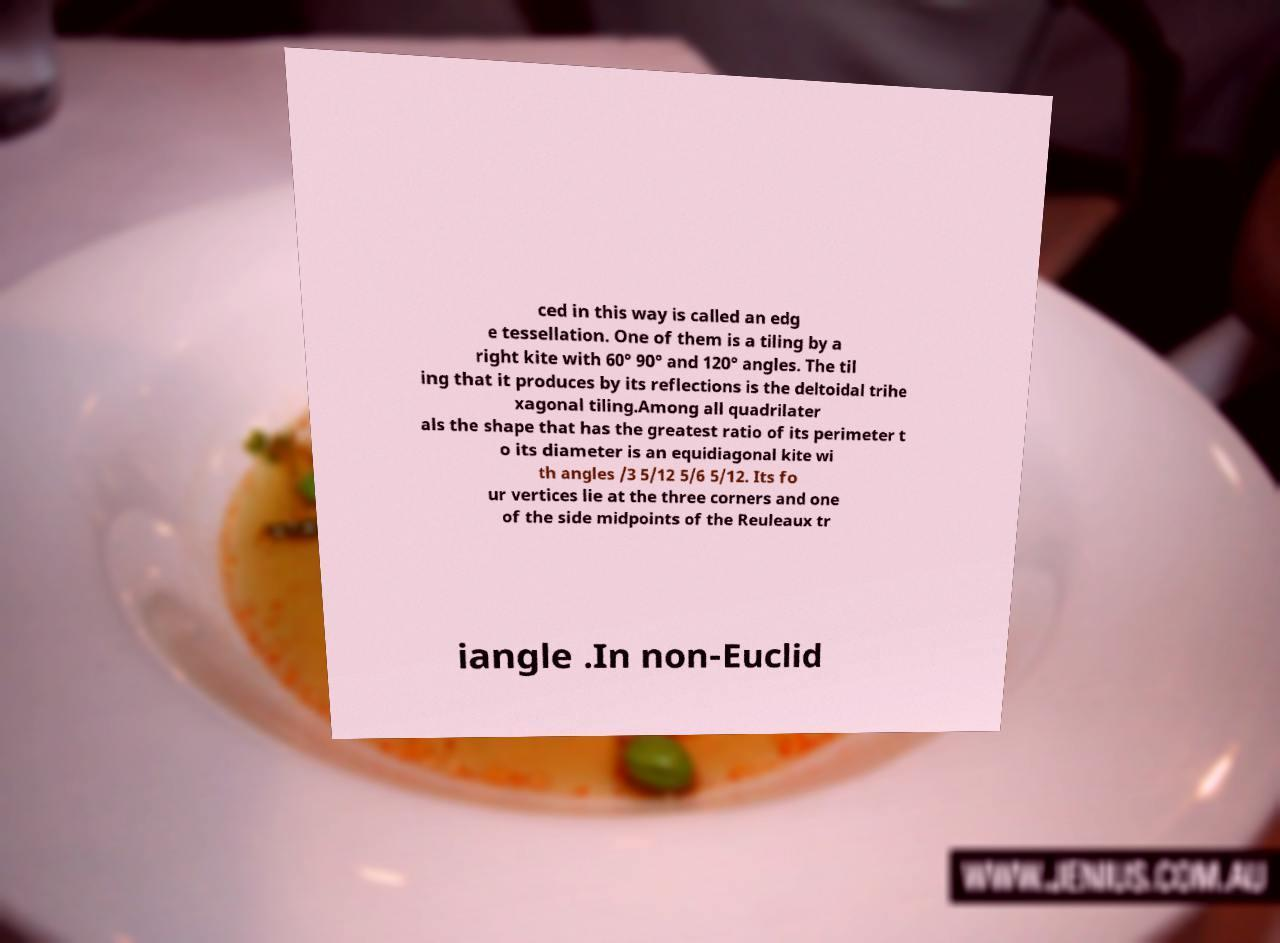Can you read and provide the text displayed in the image?This photo seems to have some interesting text. Can you extract and type it out for me? ced in this way is called an edg e tessellation. One of them is a tiling by a right kite with 60° 90° and 120° angles. The til ing that it produces by its reflections is the deltoidal trihe xagonal tiling.Among all quadrilater als the shape that has the greatest ratio of its perimeter t o its diameter is an equidiagonal kite wi th angles /3 5/12 5/6 5/12. Its fo ur vertices lie at the three corners and one of the side midpoints of the Reuleaux tr iangle .In non-Euclid 